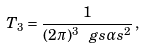<formula> <loc_0><loc_0><loc_500><loc_500>T _ { 3 } = \frac { 1 } { ( 2 \pi ) ^ { 3 } \ g s \alpha s ^ { 2 } } \, ,</formula> 